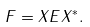Convert formula to latex. <formula><loc_0><loc_0><loc_500><loc_500>F = X E X ^ { * } .</formula> 